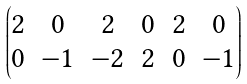Convert formula to latex. <formula><loc_0><loc_0><loc_500><loc_500>\begin{pmatrix} 2 & 0 & 2 & 0 & 2 & 0 \\ 0 & - 1 & - 2 & 2 & 0 & - 1 \end{pmatrix}</formula> 